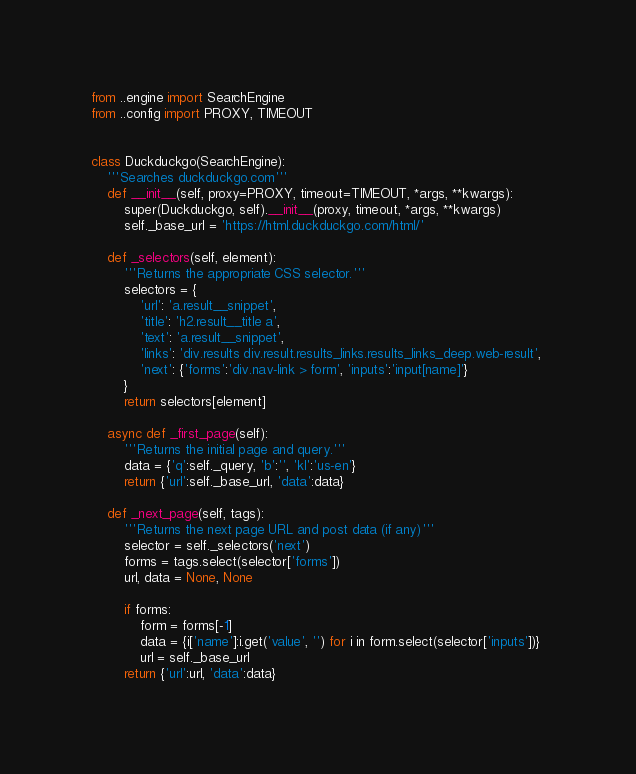<code> <loc_0><loc_0><loc_500><loc_500><_Python_>from ..engine import SearchEngine
from ..config import PROXY, TIMEOUT


class Duckduckgo(SearchEngine):
    '''Searches duckduckgo.com'''
    def __init__(self, proxy=PROXY, timeout=TIMEOUT, *args, **kwargs):
        super(Duckduckgo, self).__init__(proxy, timeout, *args, **kwargs)
        self._base_url = 'https://html.duckduckgo.com/html/'
    
    def _selectors(self, element):
        '''Returns the appropriate CSS selector.'''
        selectors = {
            'url': 'a.result__snippet', 
            'title': 'h2.result__title a', 
            'text': 'a.result__snippet', 
            'links': 'div.results div.result.results_links.results_links_deep.web-result', 
            'next': {'forms':'div.nav-link > form', 'inputs':'input[name]'}
        }
        return selectors[element]
    
    async def _first_page(self):
        '''Returns the initial page and query.'''
        data = {'q':self._query, 'b':'', 'kl':'us-en'} 
        return {'url':self._base_url, 'data':data}
    
    def _next_page(self, tags):
        '''Returns the next page URL and post data (if any)'''
        selector = self._selectors('next')
        forms = tags.select(selector['forms'])
        url, data = None, None

        if forms:
            form = forms[-1]
            data = {i['name']:i.get('value', '') for i in form.select(selector['inputs'])}
            url = self._base_url
        return {'url':url, 'data':data}
</code> 